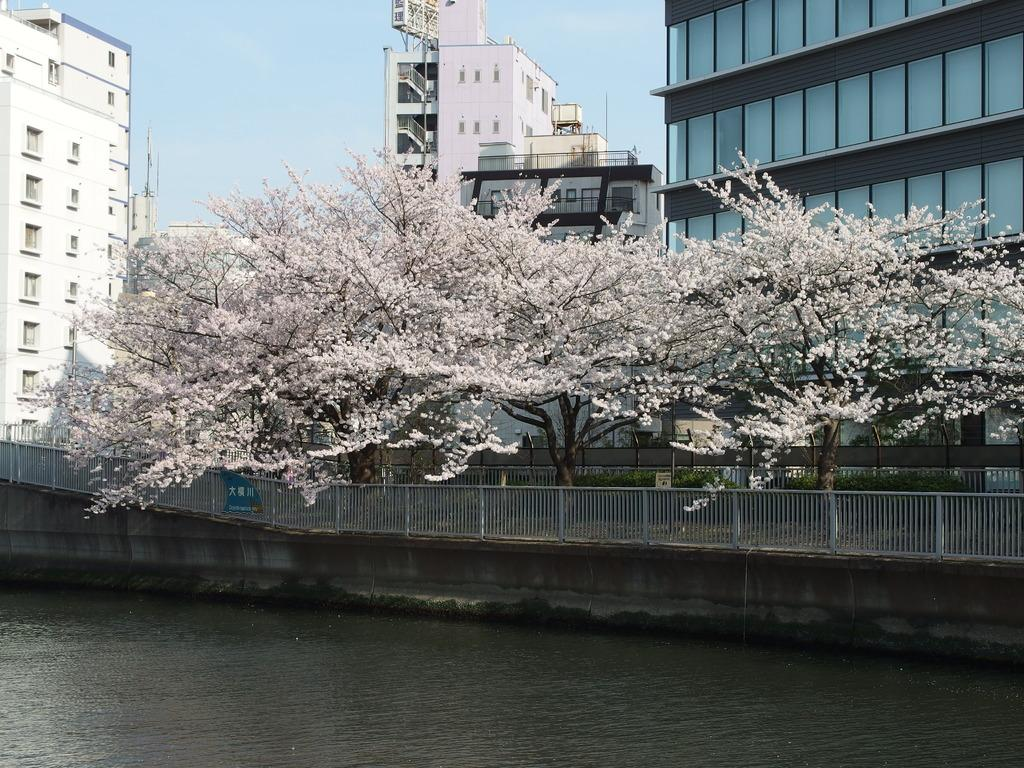What natural feature is present in the image? There is a river in the image. What is located behind the river? There is a railing behind the river. What type of vegetation is visible behind the railing? There are trees behind the railing. What structures are located behind the trees? There are buildings behind the trees. What can be seen in the background of the image? The sky is visible in the background of the image. Where are the bookshelves located in the image? There are no bookshelves present in the image. Can you describe the sidewalk near the river in the image? There is no sidewalk visible in the image; it features a river, railing, trees, buildings, and sky. 